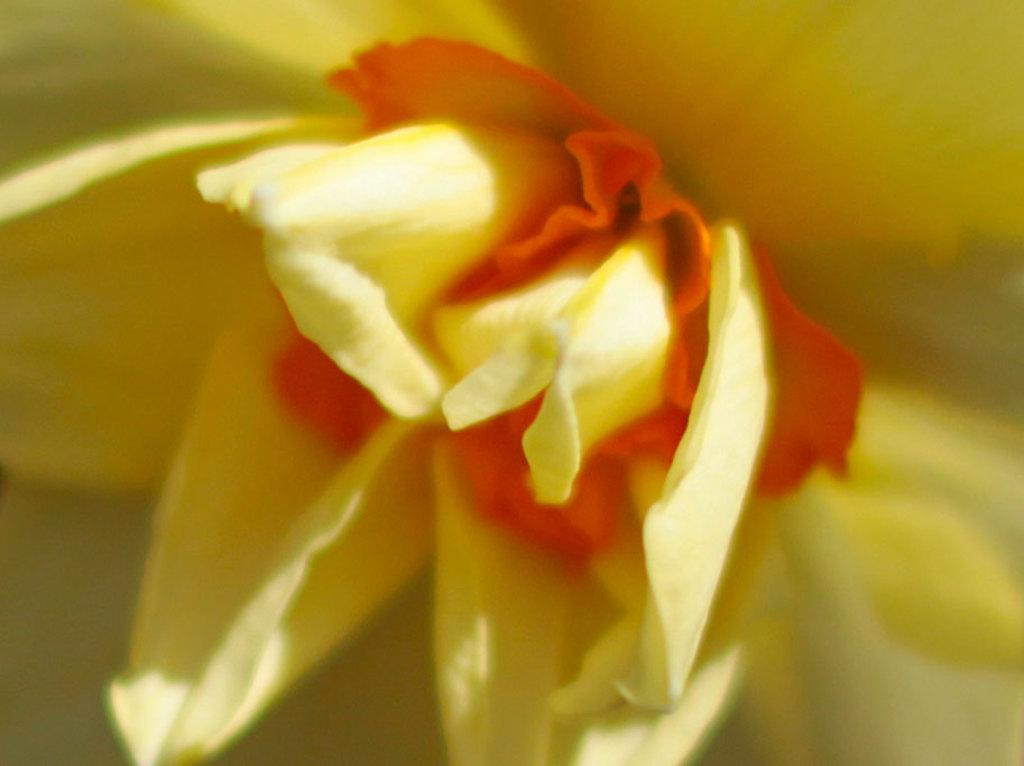What is the main subject of the image? There is a flower in the image. How does the flower contribute to the pollution in the image? There is no mention of pollution in the image, and the flower is not a source of pollution. 